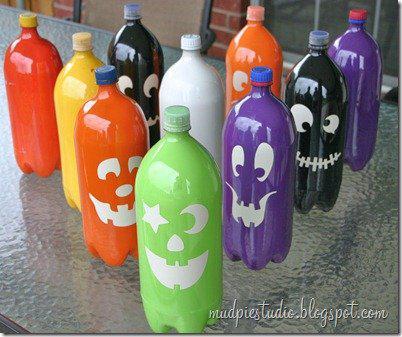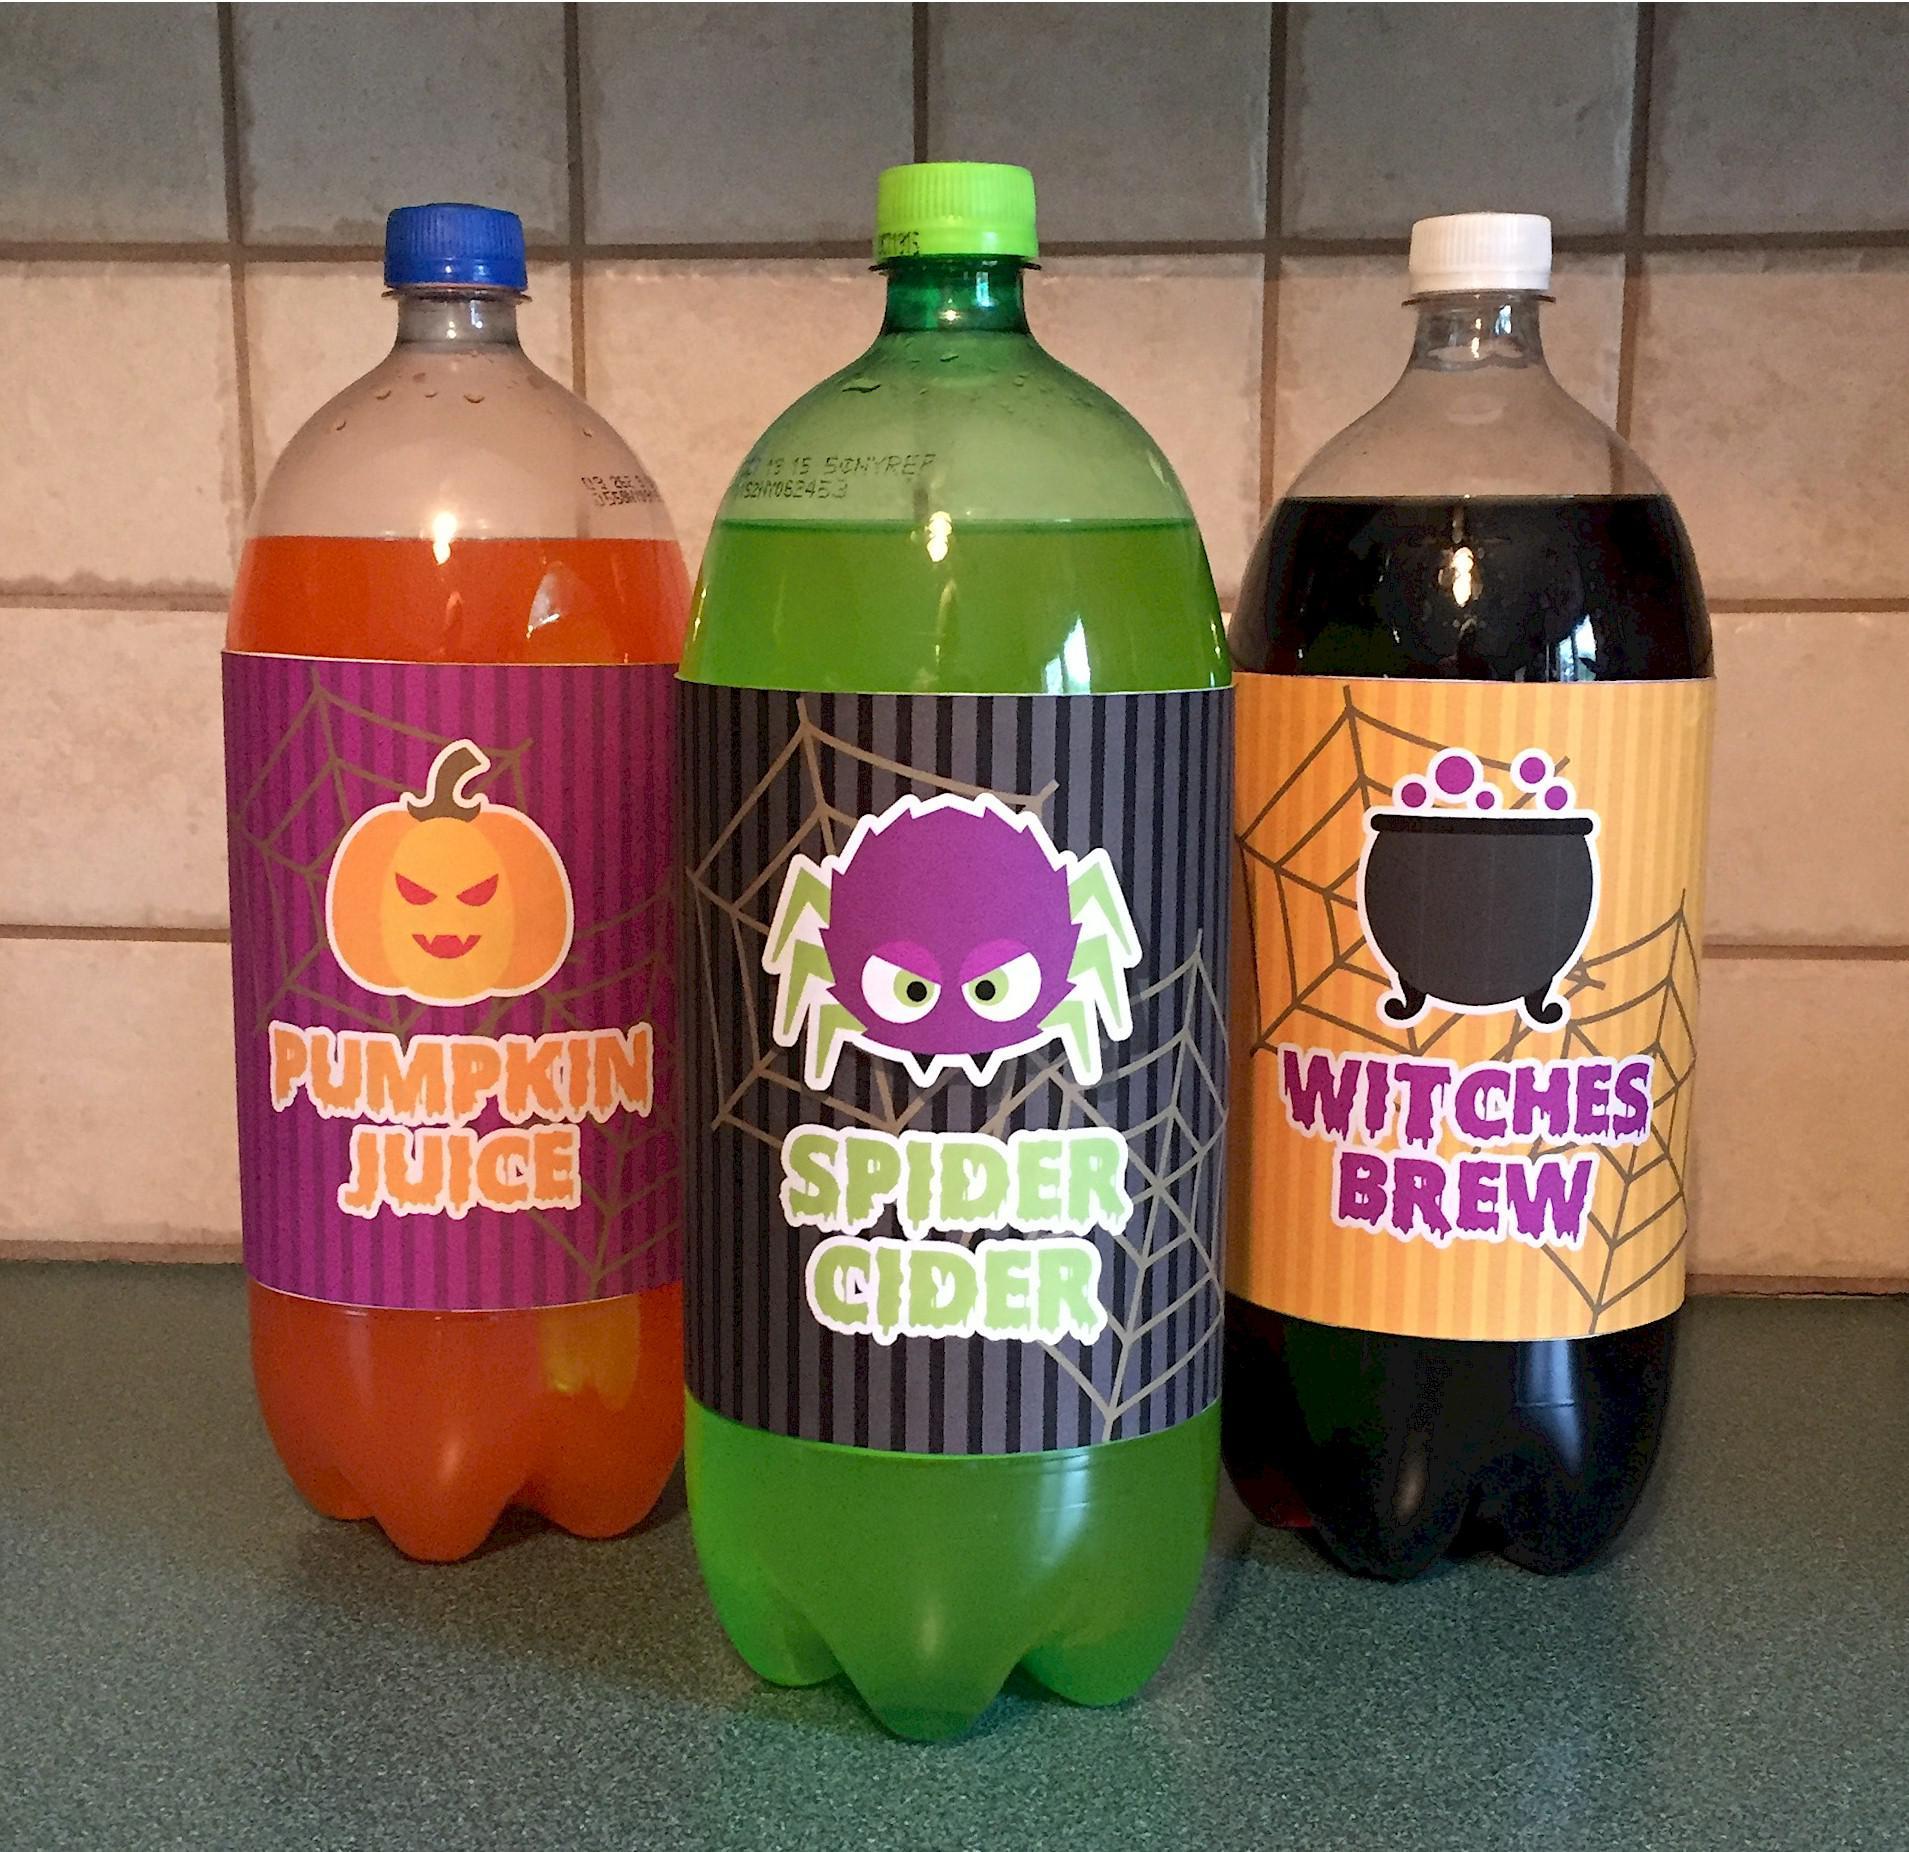The first image is the image on the left, the second image is the image on the right. For the images displayed, is the sentence "The image on the left shows four bottles, each containing a different kind of an organic drink, each with a Halloween name." factually correct? Answer yes or no. No. The first image is the image on the left, the second image is the image on the right. Given the left and right images, does the statement "There are only three bottles visible in one of the images." hold true? Answer yes or no. Yes. 